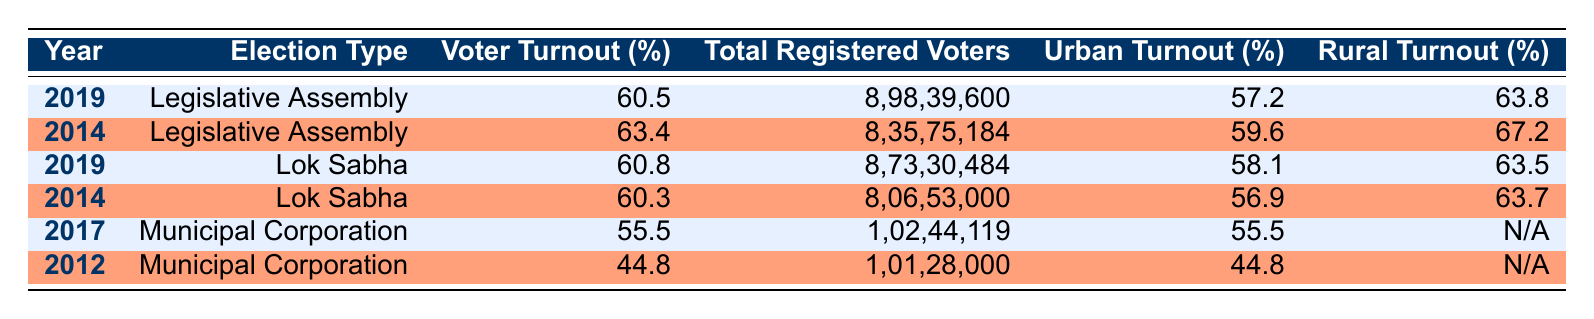What was the voter turnout percentage in the 2019 Legislative Assembly elections? The table indicates that the voter turnout for the 2019 Legislative Assembly is listed directly, which is 60.5%.
Answer: 60.5% Which election had the highest voter turnout percentage, based on the data? By comparing the voter turnout percentages from all entries, the highest value is 63.4% from the 2014 Legislative Assembly election.
Answer: 63.4% What is the total number of registered voters in the 2014 Lok Sabha elections? The table shows that the total registered voters for the 2014 Lok Sabha elections is 8,06,53,000.
Answer: 8,06,53,000 What is the difference in voter turnout percentage between the 2019 Lok Sabha elections and the 2014 Legislative Assembly elections? The voter turnout for the 2019 Lok Sabha election is 60.8% and for the 2014 Legislative Assembly, it is 63.4%. The difference is calculated as 63.4% - 60.8% = 2.6%.
Answer: 2.6% Did the urban turnout for the 2017 Municipal Corporation elections have a higher value than the rural turnout in the same year? The urban turnout for 2017 is 55.5%, while the rural turnout is marked as N/A, indicating no data. Therefore, we cannot determine if it was higher or not.
Answer: No What was the average urban voter turnout percentage across all the elections listed? The urban turnout percentages are 57.2%, 59.6%, 58.1%, 56.9%, 55.5%, and 44.8%. Adding these together gives 332.1%, and dividing by 6 gives an average of 55.35%.
Answer: 55.35% Was the rural voter turnout higher in 2014 compared to 2012 for the Municipal Corporation elections? Looking at the table, in 2014 the rural turnout (for any 2014 election) is not specifically listed for Municipal Corporation; however, for Lok Sabha, it is 63.7% and for 2012 it is N/A. Thus, a direct comparison is not possible.
Answer: No What was the total number of registered voters in the 2019 Lok Sabha elections compared to the 2017 Municipal Corporation elections? The total registered voters for the 2019 Lok Sabha elections is 8,73,30,484, while for the 2017 Municipal Corporation, it is 1,02,44,119.
Answer: 8,73,30,484 vs. 1,02,44,119 What was the voter turnout difference between the 2012 and 2017 Municipal Corporation elections? The voter turnout for the 2017 Municipal Corporation is 55.5% and for 2012, it is 44.8%. Thus, the difference is 55.5% - 44.8% = 10.7%.
Answer: 10.7% 